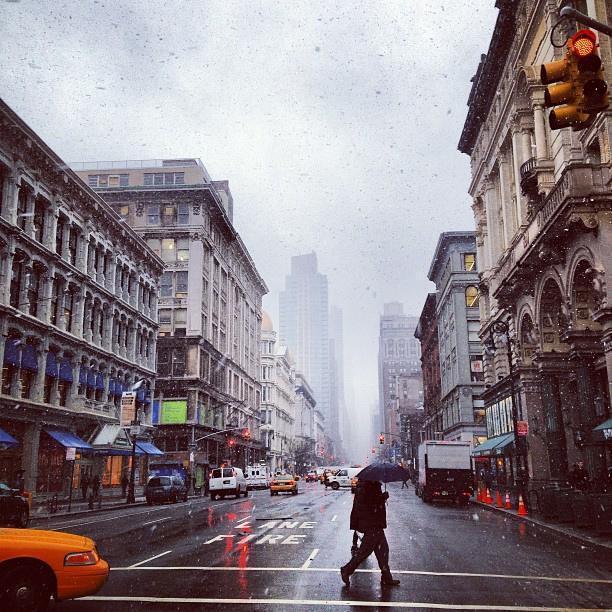What kind of vehicle can park in the middle lane?
Answer the question by selecting the correct answer among the 4 following choices and explain your choice with a short sentence. The answer should be formatted with the following format: `Answer: choice
Rationale: rationale.`
Options: Ups truck, delivery vehicle, school bus, fire truck. Answer: fire truck.
Rationale: A busy city street has the word fire printed in the middle lane of a multi lane street. fire trucks have a lane to drive in so they can get by in big cities. 